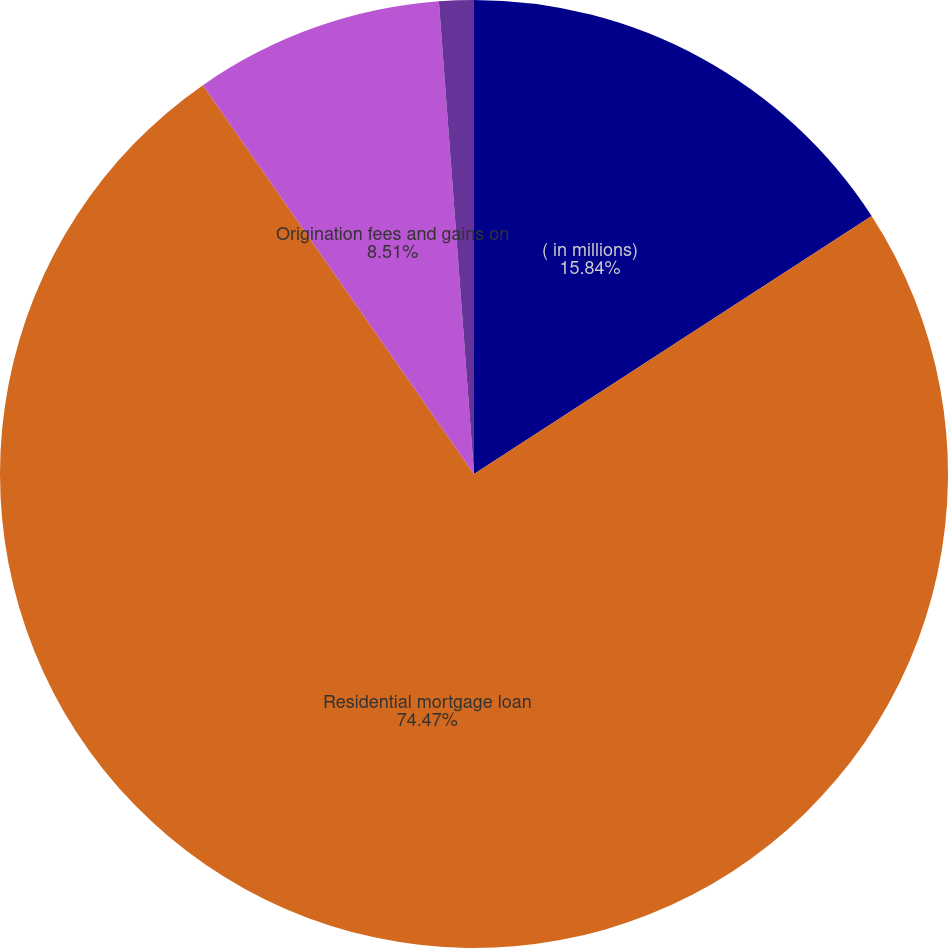Convert chart to OTSL. <chart><loc_0><loc_0><loc_500><loc_500><pie_chart><fcel>( in millions)<fcel>Residential mortgage loan<fcel>Origination fees and gains on<fcel>Servicing fees<nl><fcel>15.84%<fcel>74.47%<fcel>8.51%<fcel>1.18%<nl></chart> 